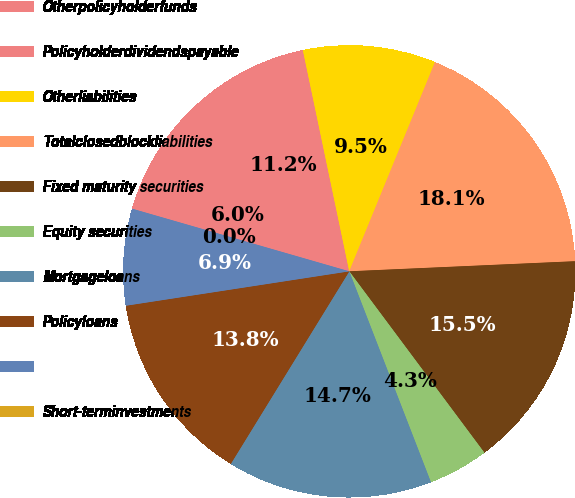<chart> <loc_0><loc_0><loc_500><loc_500><pie_chart><fcel>Otherpolicyholderfunds<fcel>Policyholderdividendspayable<fcel>Otherliabilities<fcel>Totalclosedblockliabilities<fcel>Fixed maturity securities<fcel>Equity securities<fcel>Mortgageloans<fcel>Policyloans<fcel>Unnamed: 8<fcel>Short-terminvestments<nl><fcel>6.03%<fcel>11.21%<fcel>9.48%<fcel>18.1%<fcel>15.52%<fcel>4.31%<fcel>14.66%<fcel>13.79%<fcel>6.9%<fcel>0.0%<nl></chart> 